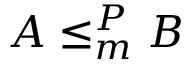Convert formula to latex. <formula><loc_0><loc_0><loc_500><loc_500>A \leq _ { m } ^ { P } B</formula> 